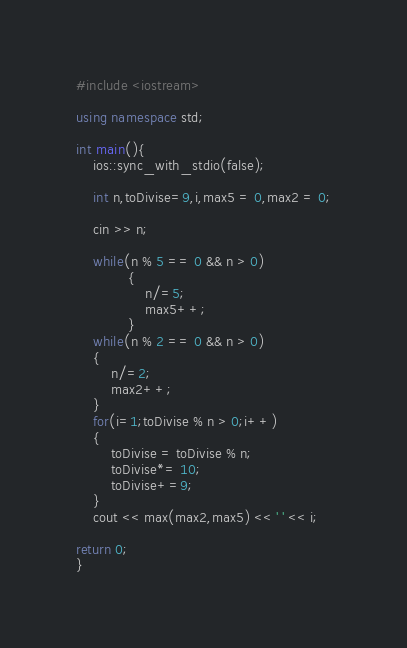<code> <loc_0><loc_0><loc_500><loc_500><_C++_>#include <iostream>

using namespace std;

int main(){
	ios::sync_with_stdio(false);
	
	int n,toDivise=9,i,max5 = 0,max2 = 0;
	
	cin >> n;
	
	while(n % 5 == 0 && n > 0)
			{
				n/=5; 
				max5++;
			}
	while(n % 2 == 0 && n > 0)
	{
		n/=2;
		max2++;
	}
	for(i=1;toDivise % n > 0;i++)
	{
		toDivise = toDivise % n; 
		toDivise*= 10;
		toDivise+=9;
	}
	cout << max(max2,max5) << ' ' << i;
	 
return 0;
}</code> 